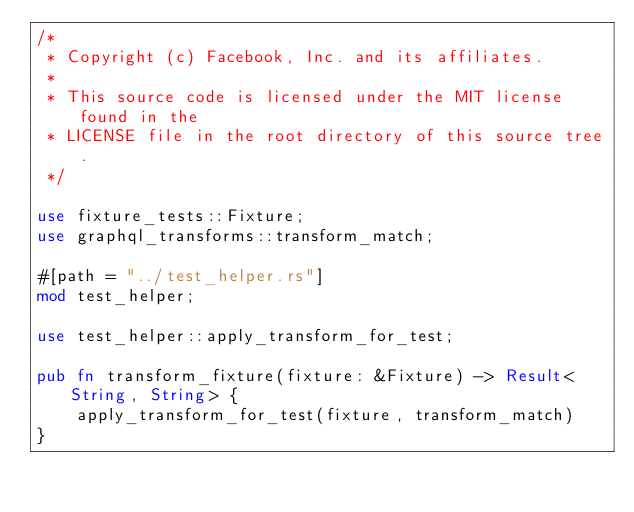Convert code to text. <code><loc_0><loc_0><loc_500><loc_500><_Rust_>/*
 * Copyright (c) Facebook, Inc. and its affiliates.
 *
 * This source code is licensed under the MIT license found in the
 * LICENSE file in the root directory of this source tree.
 */

use fixture_tests::Fixture;
use graphql_transforms::transform_match;

#[path = "../test_helper.rs"]
mod test_helper;

use test_helper::apply_transform_for_test;

pub fn transform_fixture(fixture: &Fixture) -> Result<String, String> {
    apply_transform_for_test(fixture, transform_match)
}
</code> 